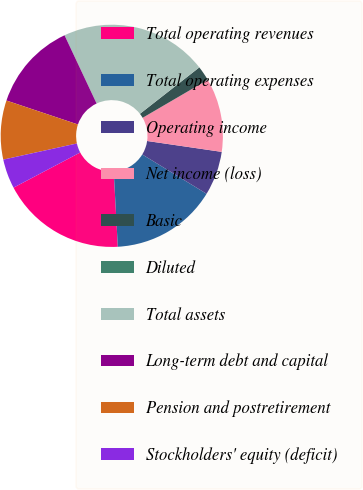Convert chart to OTSL. <chart><loc_0><loc_0><loc_500><loc_500><pie_chart><fcel>Total operating revenues<fcel>Total operating expenses<fcel>Operating income<fcel>Net income (loss)<fcel>Basic<fcel>Diluted<fcel>Total assets<fcel>Long-term debt and capital<fcel>Pension and postretirement<fcel>Stockholders' equity (deficit)<nl><fcel>18.14%<fcel>15.4%<fcel>6.43%<fcel>10.72%<fcel>2.15%<fcel>0.0%<fcel>21.43%<fcel>12.86%<fcel>8.58%<fcel>4.29%<nl></chart> 